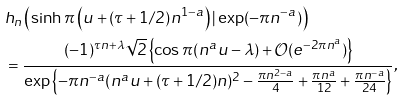Convert formula to latex. <formula><loc_0><loc_0><loc_500><loc_500>& h _ { n } \left ( \sinh \pi \left ( u + ( \tau + 1 / 2 ) n ^ { 1 - a } \right ) | \exp ( - \pi n ^ { - a } ) \right ) \\ & = \frac { ( - 1 ) ^ { \tau n + \lambda } \sqrt { 2 } \left \{ \cos \pi ( n ^ { a } u - \lambda ) + \mathcal { O } ( e ^ { - 2 \pi n ^ { a } } ) \right \} } { \exp \left \{ - \pi n ^ { - a } ( n ^ { a } u + ( \tau + 1 / 2 ) n ) ^ { 2 } - \frac { \pi n ^ { 2 - a } } { 4 } + \frac { \pi n ^ { a } } { 1 2 } + \frac { \pi n ^ { - a } } { 2 4 } \right \} } ,</formula> 